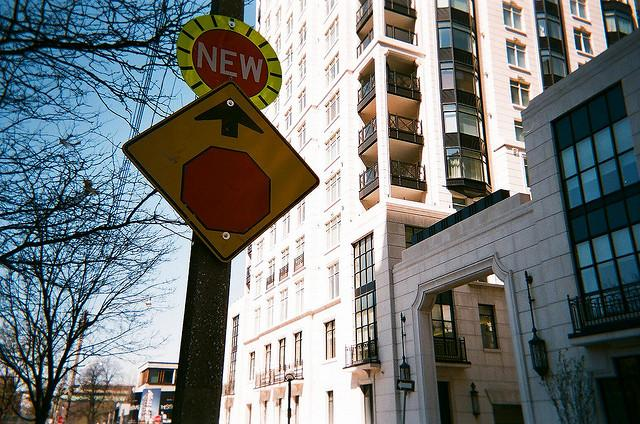The area outside the building would be described as what by a person?

Choices:
A) mild
B) warm
C) hot
D) cold cold 